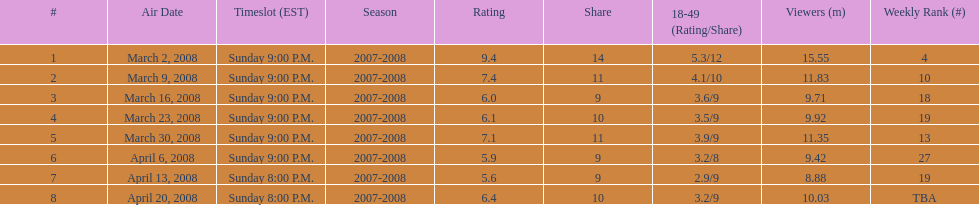How many shows had at least 10 million viewers? 4. Could you parse the entire table as a dict? {'header': ['#', 'Air Date', 'Timeslot (EST)', 'Season', 'Rating', 'Share', '18-49 (Rating/Share)', 'Viewers (m)', 'Weekly Rank (#)'], 'rows': [['1', 'March 2, 2008', 'Sunday 9:00 P.M.', '2007-2008', '9.4', '14', '5.3/12', '15.55', '4'], ['2', 'March 9, 2008', 'Sunday 9:00 P.M.', '2007-2008', '7.4', '11', '4.1/10', '11.83', '10'], ['3', 'March 16, 2008', 'Sunday 9:00 P.M.', '2007-2008', '6.0', '9', '3.6/9', '9.71', '18'], ['4', 'March 23, 2008', 'Sunday 9:00 P.M.', '2007-2008', '6.1', '10', '3.5/9', '9.92', '19'], ['5', 'March 30, 2008', 'Sunday 9:00 P.M.', '2007-2008', '7.1', '11', '3.9/9', '11.35', '13'], ['6', 'April 6, 2008', 'Sunday 9:00 P.M.', '2007-2008', '5.9', '9', '3.2/8', '9.42', '27'], ['7', 'April 13, 2008', 'Sunday 8:00 P.M.', '2007-2008', '5.6', '9', '2.9/9', '8.88', '19'], ['8', 'April 20, 2008', 'Sunday 8:00 P.M.', '2007-2008', '6.4', '10', '3.2/9', '10.03', 'TBA']]} 